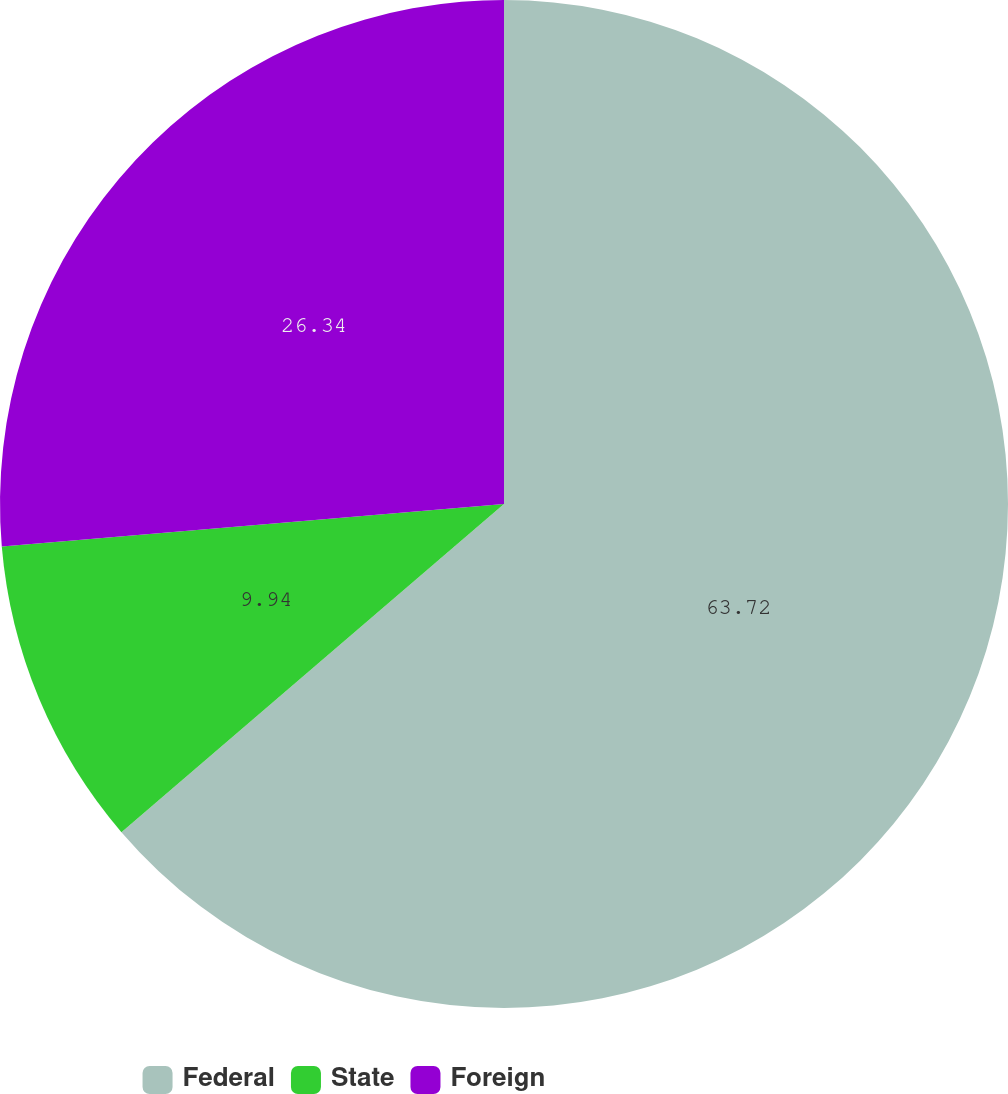<chart> <loc_0><loc_0><loc_500><loc_500><pie_chart><fcel>Federal<fcel>State<fcel>Foreign<nl><fcel>63.71%<fcel>9.94%<fcel>26.34%<nl></chart> 